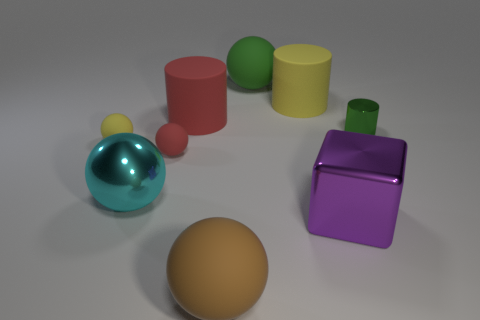There is a yellow object on the left side of the green thing behind the metal cylinder; how big is it?
Offer a very short reply. Small. What number of tiny objects are either blue matte spheres or shiny cubes?
Ensure brevity in your answer.  0. What number of other objects are the same color as the large block?
Make the answer very short. 0. Does the cylinder on the left side of the big green matte sphere have the same size as the yellow rubber object that is to the left of the cyan metal thing?
Provide a succinct answer. No. Do the small red thing and the big ball behind the large red rubber cylinder have the same material?
Offer a very short reply. Yes. Is the number of large green objects that are to the left of the tiny red matte thing greater than the number of big brown rubber balls that are behind the large purple shiny cube?
Give a very brief answer. No. What is the color of the big rubber ball that is in front of the yellow thing that is in front of the small shiny cylinder?
Your answer should be very brief. Brown. What number of blocks are big purple metal things or big brown things?
Your response must be concise. 1. How many spheres are both to the right of the small yellow thing and behind the brown ball?
Give a very brief answer. 3. What is the color of the metallic object that is in front of the metallic sphere?
Keep it short and to the point. Purple. 